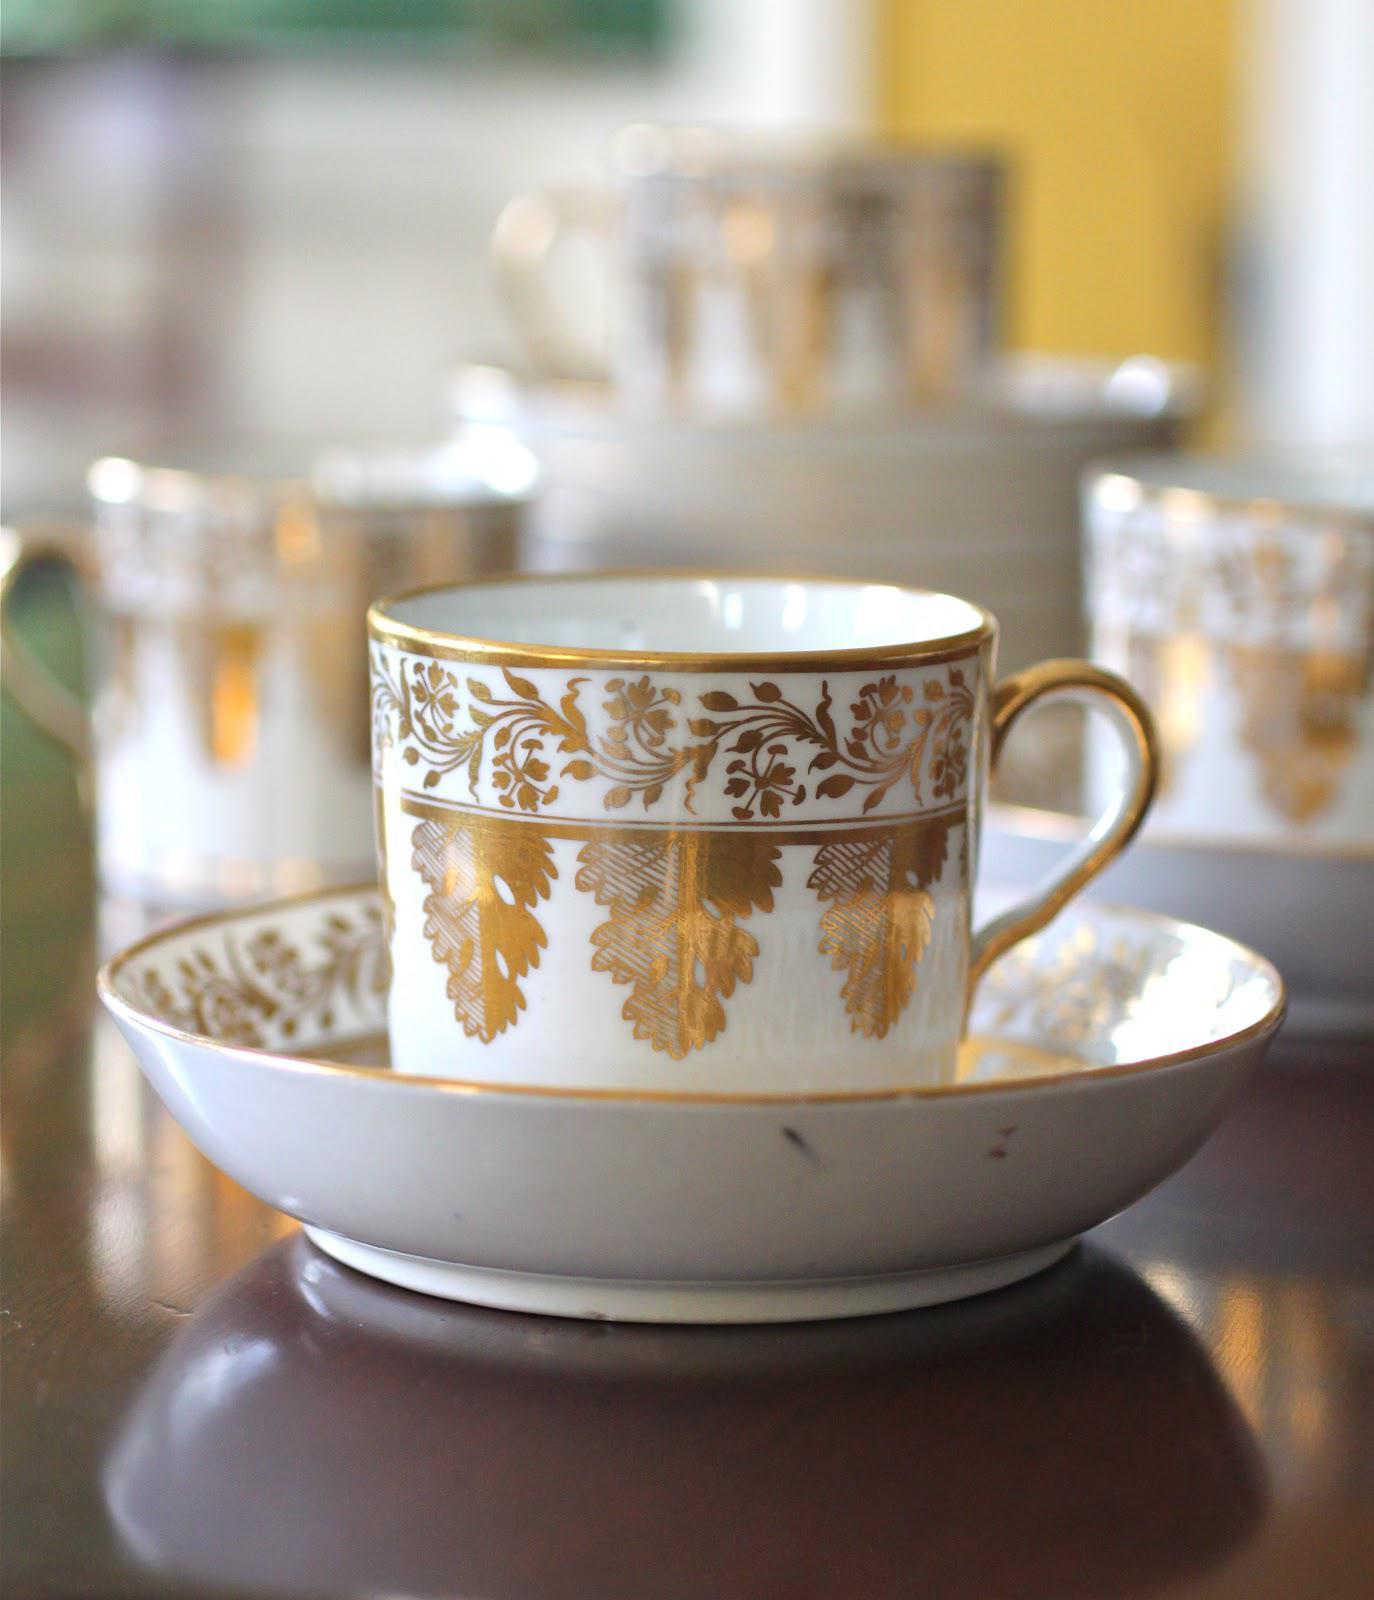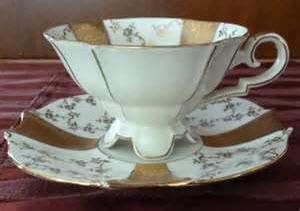The first image is the image on the left, the second image is the image on the right. For the images shown, is this caption "The left image shows a cup and saucer with pink flowers on it." true? Answer yes or no. No. The first image is the image on the left, the second image is the image on the right. For the images shown, is this caption "Both tea cups have curved or curled legs with gold paint." true? Answer yes or no. No. 